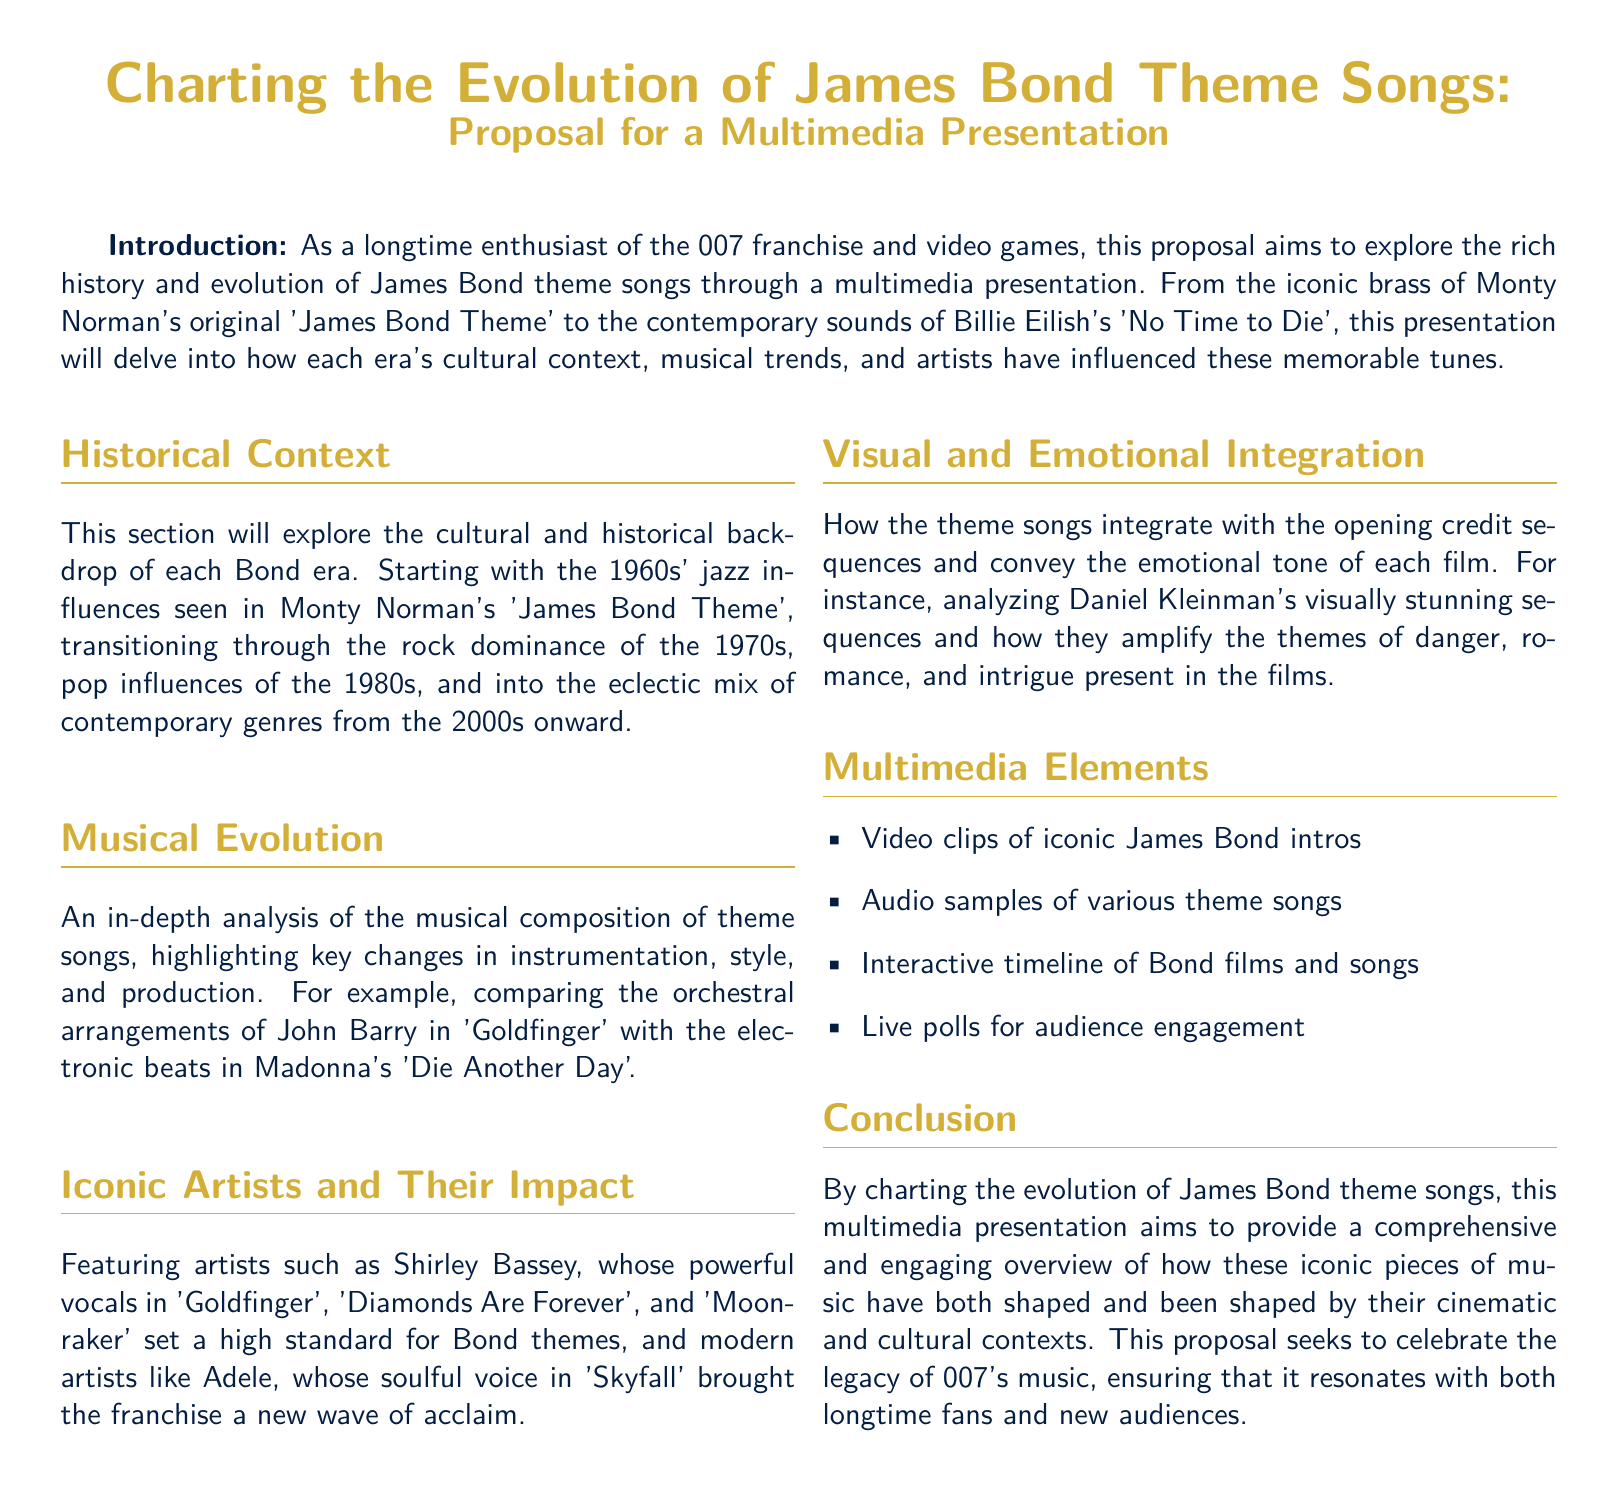What is the title of the proposal? The title of the proposal is prominently stated at the beginning of the document as “Charting the Evolution of James Bond Theme Songs.”
Answer: Charting the Evolution of James Bond Theme Songs Who composed the original 'James Bond Theme'? The document mentions that Monty Norman composed the original 'James Bond Theme.'
Answer: Monty Norman What decade is associated with jazz influences in Bond themes? The proposal states that the 1960s' jazz influences are explored in the historical context section.
Answer: 1960s Which artist is highlighted for their performance in 'Skyfall'? Adele is mentioned for her performance in the Bond theme 'Skyfall.'
Answer: Adele What type of multimedia element is included for audience engagement? The proposal lists “Live polls for audience engagement” as a multimedia element.
Answer: Live polls How many main sections are there in the document? The document includes five main sections, as outlined in the proposal.
Answer: Five Which song is compared to 'Goldfinger' in terms of orchestration? The proposal compares 'Goldfinger' with Madonna's 'Die Another Day' regarding orchestration and style.
Answer: Die Another Day What color is used for the title text? The title text color used in the document is bondgold.
Answer: bondgold 